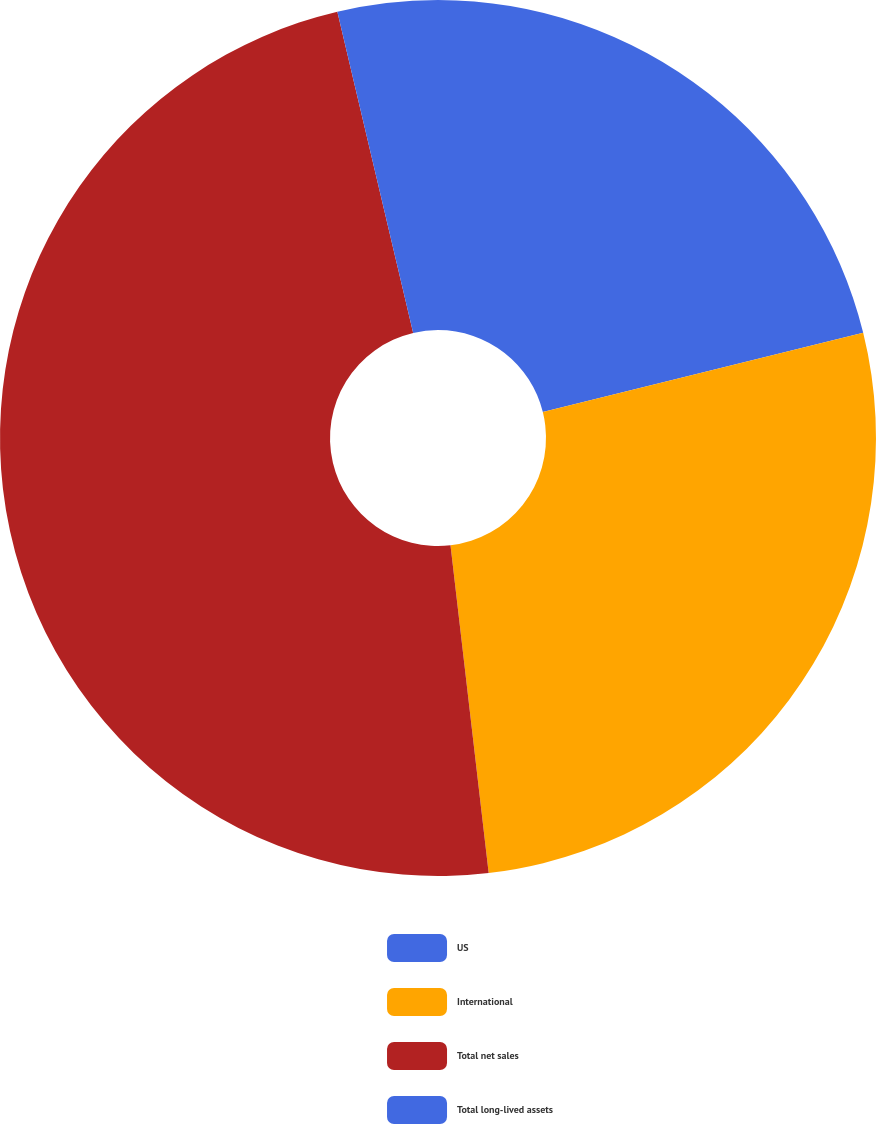Convert chart to OTSL. <chart><loc_0><loc_0><loc_500><loc_500><pie_chart><fcel>US<fcel>International<fcel>Total net sales<fcel>Total long-lived assets<nl><fcel>21.14%<fcel>27.01%<fcel>48.15%<fcel>3.69%<nl></chart> 